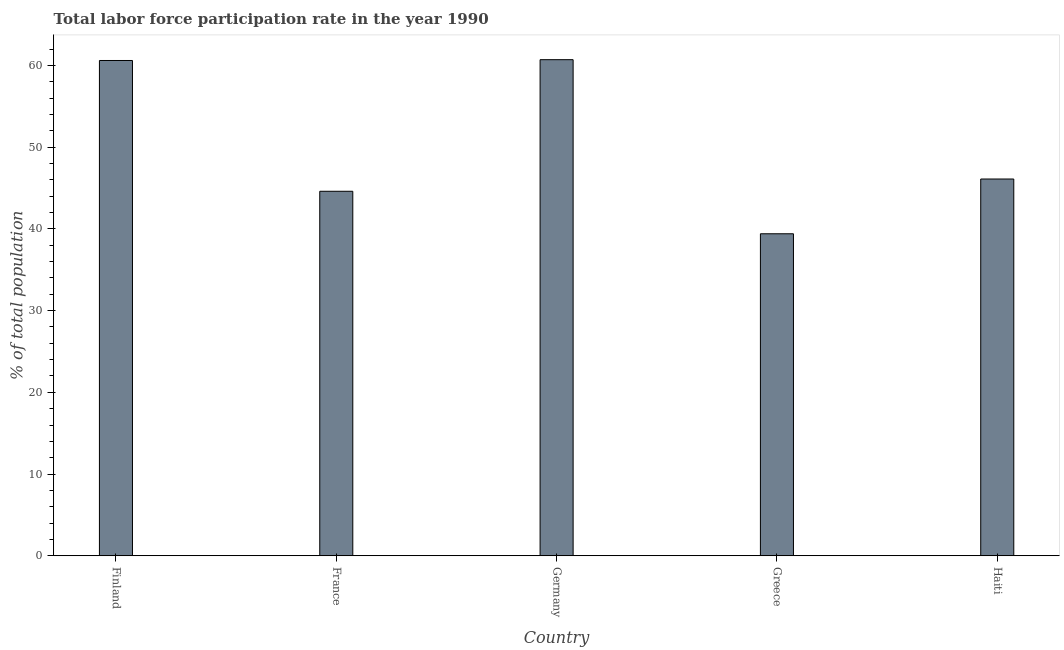Does the graph contain grids?
Your response must be concise. No. What is the title of the graph?
Provide a short and direct response. Total labor force participation rate in the year 1990. What is the label or title of the X-axis?
Provide a short and direct response. Country. What is the label or title of the Y-axis?
Your answer should be compact. % of total population. What is the total labor force participation rate in Germany?
Your answer should be very brief. 60.7. Across all countries, what is the maximum total labor force participation rate?
Offer a terse response. 60.7. Across all countries, what is the minimum total labor force participation rate?
Keep it short and to the point. 39.4. In which country was the total labor force participation rate minimum?
Keep it short and to the point. Greece. What is the sum of the total labor force participation rate?
Your response must be concise. 251.4. What is the difference between the total labor force participation rate in Finland and Germany?
Your response must be concise. -0.1. What is the average total labor force participation rate per country?
Your response must be concise. 50.28. What is the median total labor force participation rate?
Give a very brief answer. 46.1. What is the ratio of the total labor force participation rate in Finland to that in Greece?
Give a very brief answer. 1.54. Is the difference between the total labor force participation rate in Finland and Germany greater than the difference between any two countries?
Provide a short and direct response. No. What is the difference between the highest and the lowest total labor force participation rate?
Give a very brief answer. 21.3. In how many countries, is the total labor force participation rate greater than the average total labor force participation rate taken over all countries?
Make the answer very short. 2. How many bars are there?
Provide a short and direct response. 5. Are all the bars in the graph horizontal?
Provide a succinct answer. No. What is the difference between two consecutive major ticks on the Y-axis?
Provide a succinct answer. 10. What is the % of total population in Finland?
Your response must be concise. 60.6. What is the % of total population of France?
Your response must be concise. 44.6. What is the % of total population of Germany?
Your answer should be very brief. 60.7. What is the % of total population in Greece?
Keep it short and to the point. 39.4. What is the % of total population of Haiti?
Ensure brevity in your answer.  46.1. What is the difference between the % of total population in Finland and France?
Your answer should be very brief. 16. What is the difference between the % of total population in Finland and Germany?
Your answer should be very brief. -0.1. What is the difference between the % of total population in Finland and Greece?
Ensure brevity in your answer.  21.2. What is the difference between the % of total population in France and Germany?
Your answer should be very brief. -16.1. What is the difference between the % of total population in Germany and Greece?
Your answer should be compact. 21.3. What is the ratio of the % of total population in Finland to that in France?
Give a very brief answer. 1.36. What is the ratio of the % of total population in Finland to that in Germany?
Keep it short and to the point. 1. What is the ratio of the % of total population in Finland to that in Greece?
Your response must be concise. 1.54. What is the ratio of the % of total population in Finland to that in Haiti?
Make the answer very short. 1.31. What is the ratio of the % of total population in France to that in Germany?
Your answer should be compact. 0.73. What is the ratio of the % of total population in France to that in Greece?
Your answer should be compact. 1.13. What is the ratio of the % of total population in France to that in Haiti?
Keep it short and to the point. 0.97. What is the ratio of the % of total population in Germany to that in Greece?
Your answer should be very brief. 1.54. What is the ratio of the % of total population in Germany to that in Haiti?
Give a very brief answer. 1.32. What is the ratio of the % of total population in Greece to that in Haiti?
Your answer should be very brief. 0.85. 